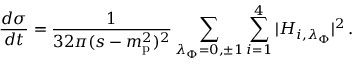<formula> <loc_0><loc_0><loc_500><loc_500>\frac { d \sigma } { d t } = \frac { 1 } { 3 2 \pi ( s - m _ { p } ^ { 2 } ) ^ { 2 } } \sum _ { \lambda _ { \Phi } = 0 , \pm 1 } \sum _ { i = 1 } ^ { 4 } | H _ { i , \lambda _ { \Phi } } | ^ { 2 } \, .</formula> 